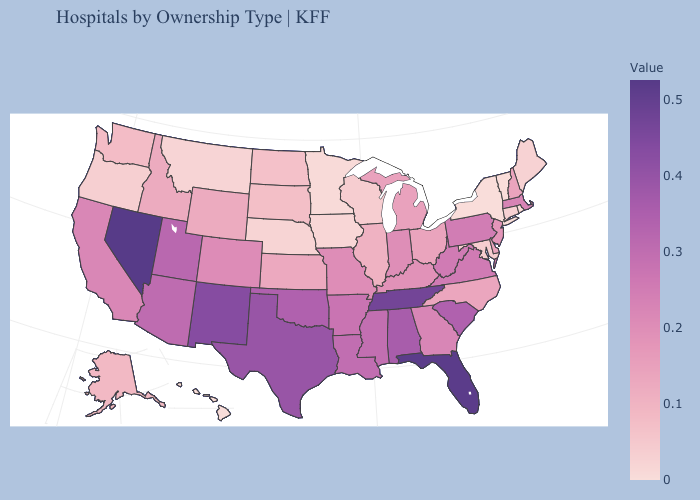Does Vermont have the highest value in the USA?
Give a very brief answer. No. Among the states that border Arkansas , which have the lowest value?
Be succinct. Missouri. Among the states that border Montana , which have the lowest value?
Write a very short answer. North Dakota. 